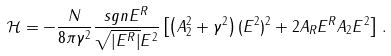<formula> <loc_0><loc_0><loc_500><loc_500>\mathcal { H } = - \frac { N } { 8 \pi \gamma ^ { 2 } } \frac { s g n E ^ { R } } { \sqrt { | E ^ { R } | } E ^ { 2 } } \left [ \left ( A _ { 2 } ^ { 2 } + \gamma ^ { 2 } \right ) ( E ^ { 2 } ) ^ { 2 } + 2 A _ { R } E ^ { R } A _ { 2 } E ^ { 2 } \right ] \, .</formula> 